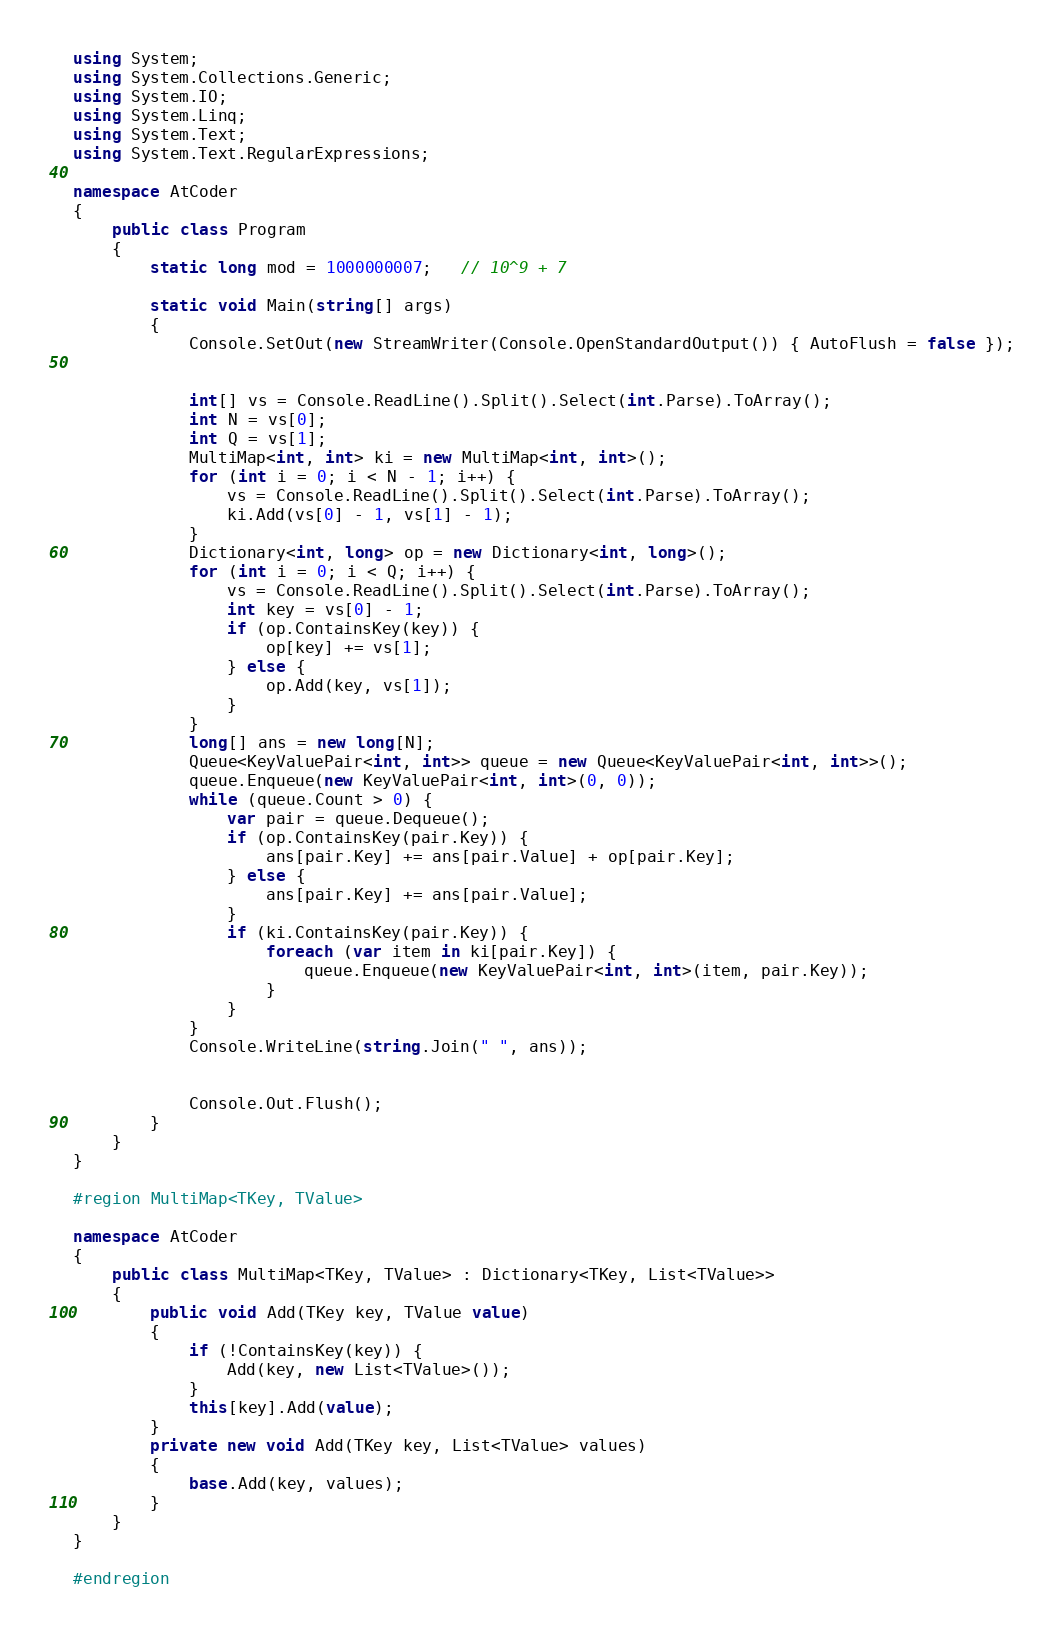<code> <loc_0><loc_0><loc_500><loc_500><_C#_>using System;
using System.Collections.Generic;
using System.IO;
using System.Linq;
using System.Text;
using System.Text.RegularExpressions;

namespace AtCoder
{
	public class Program
	{
		static long mod = 1000000007;   // 10^9 + 7

		static void Main(string[] args)
		{
			Console.SetOut(new StreamWriter(Console.OpenStandardOutput()) { AutoFlush = false });


			int[] vs = Console.ReadLine().Split().Select(int.Parse).ToArray();
			int N = vs[0];
			int Q = vs[1];
			MultiMap<int, int> ki = new MultiMap<int, int>();
			for (int i = 0; i < N - 1; i++) {
				vs = Console.ReadLine().Split().Select(int.Parse).ToArray();
				ki.Add(vs[0] - 1, vs[1] - 1);
			}
			Dictionary<int, long> op = new Dictionary<int, long>();
			for (int i = 0; i < Q; i++) {
				vs = Console.ReadLine().Split().Select(int.Parse).ToArray();
				int key = vs[0] - 1;
				if (op.ContainsKey(key)) {
					op[key] += vs[1];
				} else {
					op.Add(key, vs[1]);
				}
			}
			long[] ans = new long[N];
			Queue<KeyValuePair<int, int>> queue = new Queue<KeyValuePair<int, int>>();
			queue.Enqueue(new KeyValuePair<int, int>(0, 0));
			while (queue.Count > 0) {
				var pair = queue.Dequeue();
				if (op.ContainsKey(pair.Key)) {
					ans[pair.Key] += ans[pair.Value] + op[pair.Key];
				} else {
					ans[pair.Key] += ans[pair.Value];
				}
				if (ki.ContainsKey(pair.Key)) {
					foreach (var item in ki[pair.Key]) {
						queue.Enqueue(new KeyValuePair<int, int>(item, pair.Key));
					}
				}
			}
			Console.WriteLine(string.Join(" ", ans));


			Console.Out.Flush();
		}
	}
}

#region MultiMap<TKey, TValue>

namespace AtCoder
{
	public class MultiMap<TKey, TValue> : Dictionary<TKey, List<TValue>>
	{
		public void Add(TKey key, TValue value)
		{
			if (!ContainsKey(key)) {
				Add(key, new List<TValue>());
			}
			this[key].Add(value);
		}
		private new void Add(TKey key, List<TValue> values)
		{
			base.Add(key, values);
		}
	}
}

#endregion
</code> 